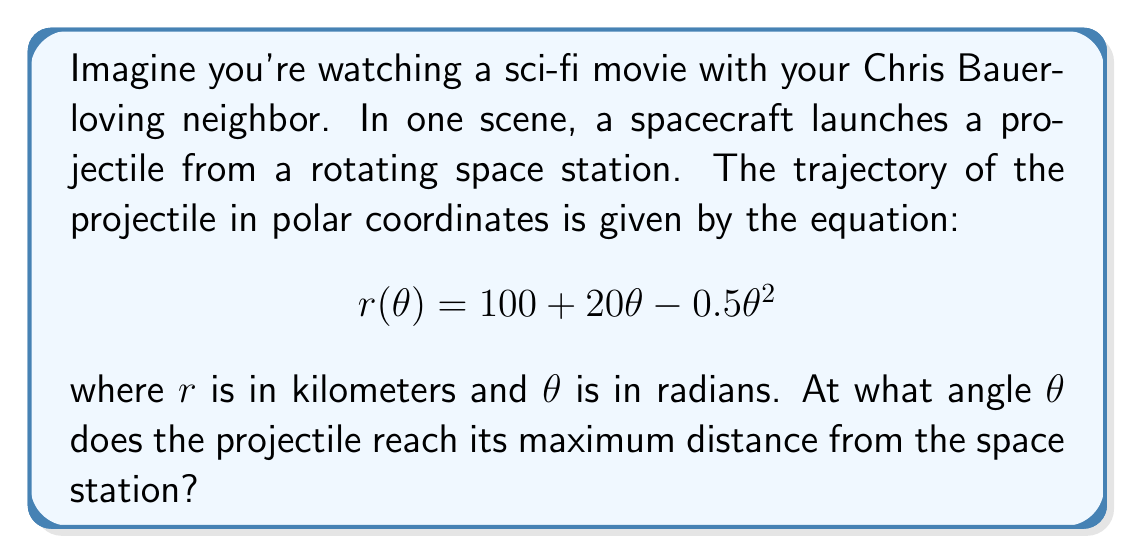Teach me how to tackle this problem. To find the angle at which the projectile reaches its maximum distance from the space station, we need to find the maximum value of $r(\theta)$. This occurs when the derivative of $r(\theta)$ with respect to $\theta$ is zero.

1) First, let's find the derivative of $r(\theta)$:
   $$\frac{dr}{d\theta} = 20 - \theta$$

2) Set this equal to zero and solve for $\theta$:
   $$20 - \theta = 0$$
   $$\theta = 20$$

3) To confirm this is a maximum and not a minimum, we can check the second derivative:
   $$\frac{d^2r}{d\theta^2} = -1$$

   Since this is negative, we confirm that $\theta = 20$ gives a maximum.

4) We should also check the endpoints of any reasonable domain for $\theta$. Since $r$ represents distance, it should be positive. Let's solve $r(\theta) = 0$:

   $$100 + 20\theta - 0.5\theta^2 = 0$$
   $$0.5\theta^2 - 20\theta - 100 = 0$$

   Using the quadratic formula, we get $\theta \approx -8.3$ or $\theta \approx 48.3$

   So our domain is approximately $-8.3 \leq \theta \leq 48.3$

5) Checking these endpoints:
   $r(-8.3) \approx 0$ km
   $r(48.3) \approx 0$ km
   $r(20) = 100 + 20(20) - 0.5(20)^2 = 300$ km

Therefore, the maximum occurs at $\theta = 20$ radians.
Answer: The projectile reaches its maximum distance from the space station at an angle of 20 radians. 